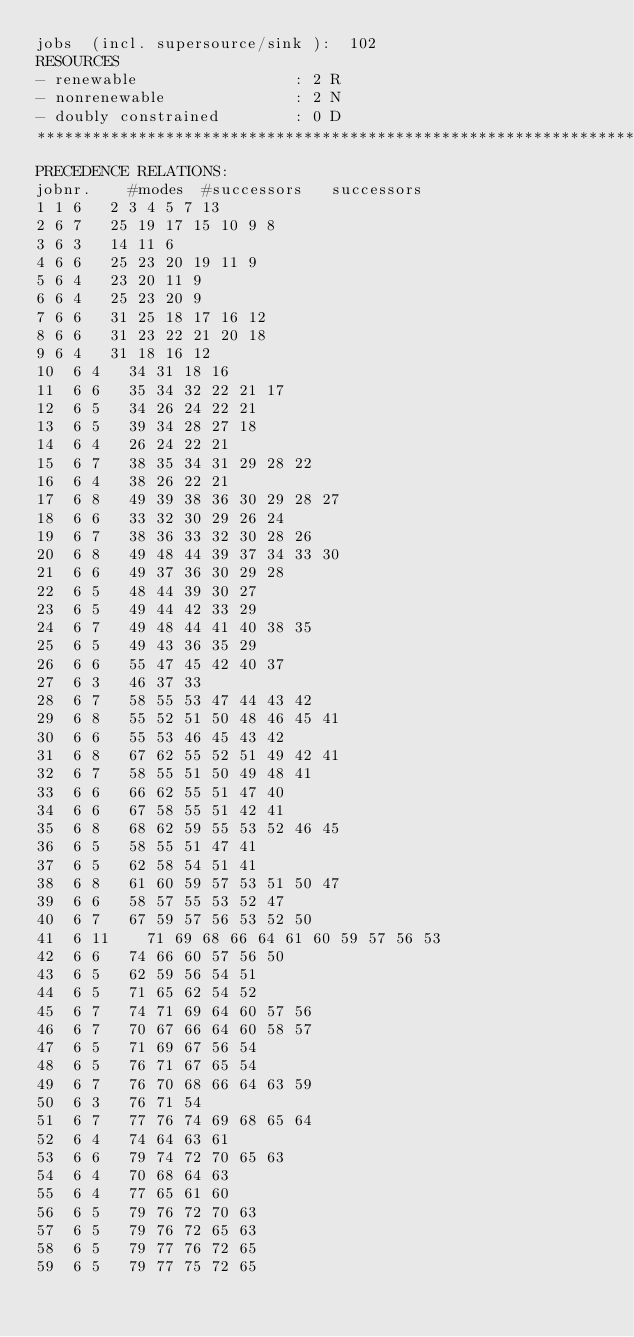Convert code to text. <code><loc_0><loc_0><loc_500><loc_500><_ObjectiveC_>jobs  (incl. supersource/sink ):	102
RESOURCES
- renewable                 : 2 R
- nonrenewable              : 2 N
- doubly constrained        : 0 D
************************************************************************
PRECEDENCE RELATIONS:
jobnr.    #modes  #successors   successors
1	1	6		2 3 4 5 7 13 
2	6	7		25 19 17 15 10 9 8 
3	6	3		14 11 6 
4	6	6		25 23 20 19 11 9 
5	6	4		23 20 11 9 
6	6	4		25 23 20 9 
7	6	6		31 25 18 17 16 12 
8	6	6		31 23 22 21 20 18 
9	6	4		31 18 16 12 
10	6	4		34 31 18 16 
11	6	6		35 34 32 22 21 17 
12	6	5		34 26 24 22 21 
13	6	5		39 34 28 27 18 
14	6	4		26 24 22 21 
15	6	7		38 35 34 31 29 28 22 
16	6	4		38 26 22 21 
17	6	8		49 39 38 36 30 29 28 27 
18	6	6		33 32 30 29 26 24 
19	6	7		38 36 33 32 30 28 26 
20	6	8		49 48 44 39 37 34 33 30 
21	6	6		49 37 36 30 29 28 
22	6	5		48 44 39 30 27 
23	6	5		49 44 42 33 29 
24	6	7		49 48 44 41 40 38 35 
25	6	5		49 43 36 35 29 
26	6	6		55 47 45 42 40 37 
27	6	3		46 37 33 
28	6	7		58 55 53 47 44 43 42 
29	6	8		55 52 51 50 48 46 45 41 
30	6	6		55 53 46 45 43 42 
31	6	8		67 62 55 52 51 49 42 41 
32	6	7		58 55 51 50 49 48 41 
33	6	6		66 62 55 51 47 40 
34	6	6		67 58 55 51 42 41 
35	6	8		68 62 59 55 53 52 46 45 
36	6	5		58 55 51 47 41 
37	6	5		62 58 54 51 41 
38	6	8		61 60 59 57 53 51 50 47 
39	6	6		58 57 55 53 52 47 
40	6	7		67 59 57 56 53 52 50 
41	6	11		71 69 68 66 64 61 60 59 57 56 53 
42	6	6		74 66 60 57 56 50 
43	6	5		62 59 56 54 51 
44	6	5		71 65 62 54 52 
45	6	7		74 71 69 64 60 57 56 
46	6	7		70 67 66 64 60 58 57 
47	6	5		71 69 67 56 54 
48	6	5		76 71 67 65 54 
49	6	7		76 70 68 66 64 63 59 
50	6	3		76 71 54 
51	6	7		77 76 74 69 68 65 64 
52	6	4		74 64 63 61 
53	6	6		79 74 72 70 65 63 
54	6	4		70 68 64 63 
55	6	4		77 65 61 60 
56	6	5		79 76 72 70 63 
57	6	5		79 76 72 65 63 
58	6	5		79 77 76 72 65 
59	6	5		79 77 75 72 65 </code> 